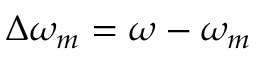<formula> <loc_0><loc_0><loc_500><loc_500>\Delta \omega _ { m } = \omega - \omega _ { m }</formula> 